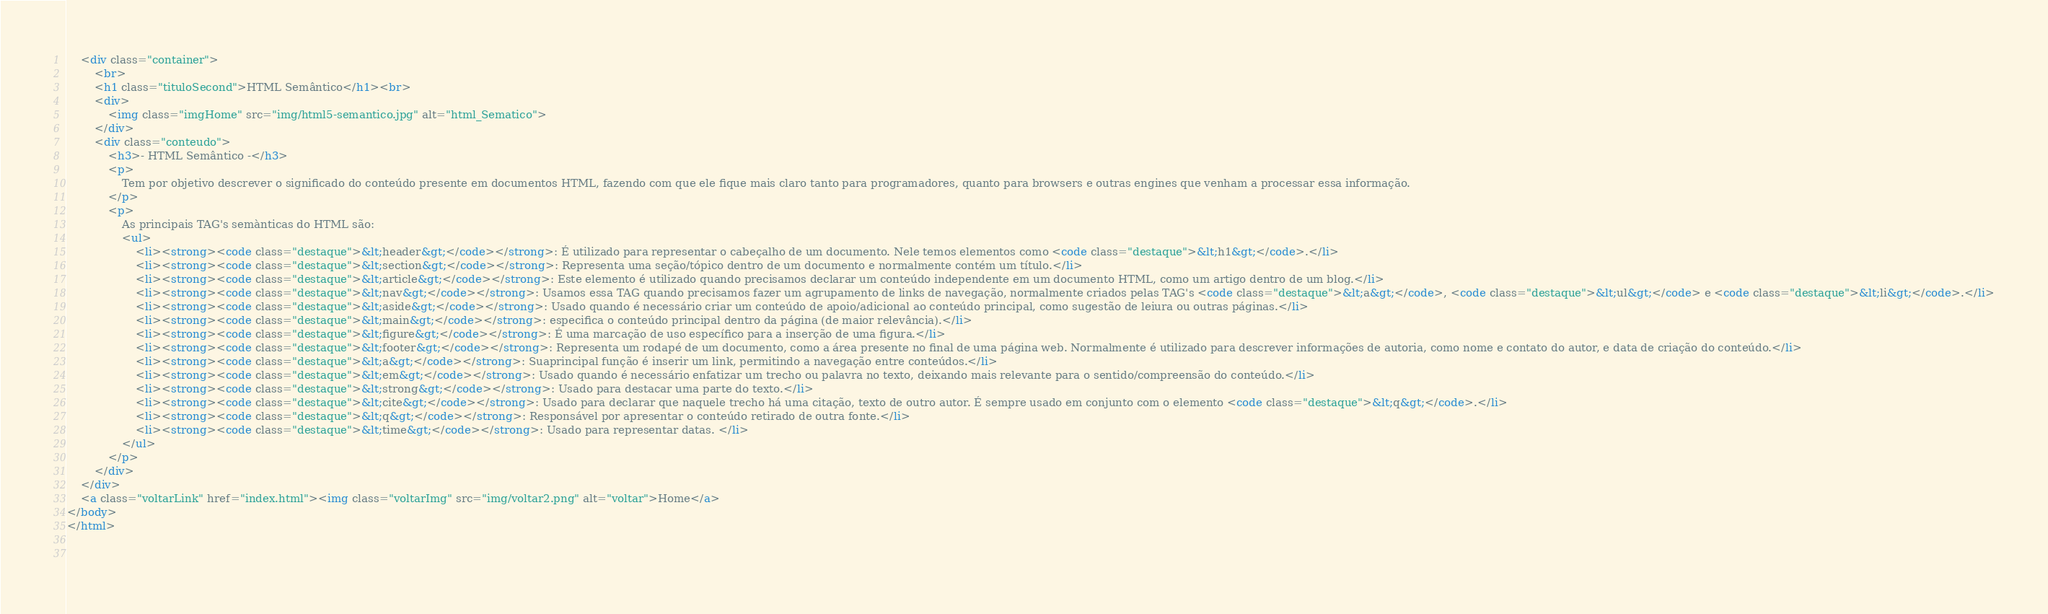<code> <loc_0><loc_0><loc_500><loc_500><_HTML_>    <div class="container">
        <br>
        <h1 class="tituloSecond">HTML Semântico</h1><br>
        <div>
            <img class="imgHome" src="img/html5-semantico.jpg" alt="html_Sematico">            
        </div>
        <div class="conteudo">
            <h3>- HTML Semântico -</h3>
            <p>
                Tem por objetivo descrever o significado do conteúdo presente em documentos HTML, fazendo com que ele fique mais claro tanto para programadores, quanto para browsers e outras engines que venham a processar essa informação.
            </p>
            <p> 
                As principais TAG's semànticas do HTML são:
                <ul>
                    <li><strong><code class="destaque">&lt;header&gt;</code></strong>: É utilizado para representar o cabeçalho de um documento. Nele temos elementos como <code class="destaque">&lt;h1&gt;</code>.</li>
                    <li><strong><code class="destaque">&lt;section&gt;</code></strong>: Representa uma seção/tópico dentro de um documento e normalmente contém um título.</li>
                    <li><strong><code class="destaque">&lt;article&gt;</code></strong>: Este elemento é utilizado quando precisamos declarar um conteúdo independente em um documento HTML, como um artigo dentro de um blog.</li>
                    <li><strong><code class="destaque">&lt;nav&gt;</code></strong>: Usamos essa TAG quando precisamos fazer um agrupamento de links de navegação, normalmente criados pelas TAG's <code class="destaque">&lt;a&gt;</code>, <code class="destaque">&lt;ul&gt;</code> e <code class="destaque">&lt;li&gt;</code>.</li>
                    <li><strong><code class="destaque">&lt;aside&gt;</code></strong>: Usado quando é necessário criar um conteúdo de apoio/adicional ao conteúdo principal, como sugestão de leiura ou outras páginas.</li>
                    <li><strong><code class="destaque">&lt;main&gt;</code></strong>: especifica o conteúdo principal dentro da página (de maior relevância).</li>
                    <li><strong><code class="destaque">&lt;figure&gt;</code></strong>: É uma marcação de uso específico para a inserção de uma figura.</li>
                    <li><strong><code class="destaque">&lt;footer&gt;</code></strong>: Representa um rodapé de um documento, como a área presente no final de uma página web. Normalmente é utilizado para descrever informações de autoria, como nome e contato do autor, e data de criação do conteúdo.</li>
                    <li><strong><code class="destaque">&lt;a&gt;</code></strong>: Suaprincipal função é inserir um link, permitindo a navegação entre conteúdos.</li>
                    <li><strong><code class="destaque">&lt;em&gt;</code></strong>: Usado quando é necessário enfatizar um trecho ou palavra no texto, deixando mais relevante para o sentido/compreensão do conteúdo.</li>
                    <li><strong><code class="destaque">&lt;strong&gt;</code></strong>: Usado para destacar uma parte do texto.</li>
                    <li><strong><code class="destaque">&lt;cite&gt;</code></strong>: Usado para declarar que naquele trecho há uma citação, texto de outro autor. É sempre usado em conjunto com o elemento <code class="destaque">&lt;q&gt;</code>.</li>
                    <li><strong><code class="destaque">&lt;q&gt;</code></strong>: Responsável por apresentar o conteúdo retirado de outra fonte.</li>
                    <li><strong><code class="destaque">&lt;time&gt;</code></strong>: Usado para representar datas. </li>
                </ul>
            </p>
        </div>  
    </div>
    <a class="voltarLink" href="index.html"><img class="voltarImg" src="img/voltar2.png" alt="voltar">Home</a>
</body>
</html>

   </code> 